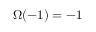Convert formula to latex. <formula><loc_0><loc_0><loc_500><loc_500>\Omega ( - 1 ) = - 1</formula> 